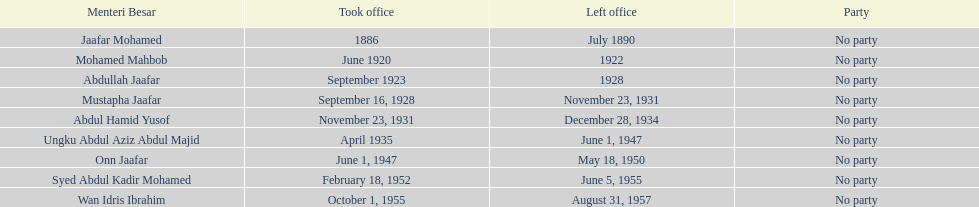How many years was jaafar mohamed in office? 4. 